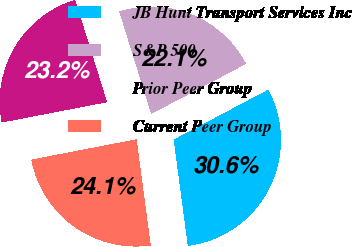Convert chart. <chart><loc_0><loc_0><loc_500><loc_500><pie_chart><fcel>JB Hunt Transport Services Inc<fcel>S&P 500<fcel>Prior Peer Group<fcel>Current Peer Group<nl><fcel>30.64%<fcel>22.08%<fcel>23.22%<fcel>24.07%<nl></chart> 